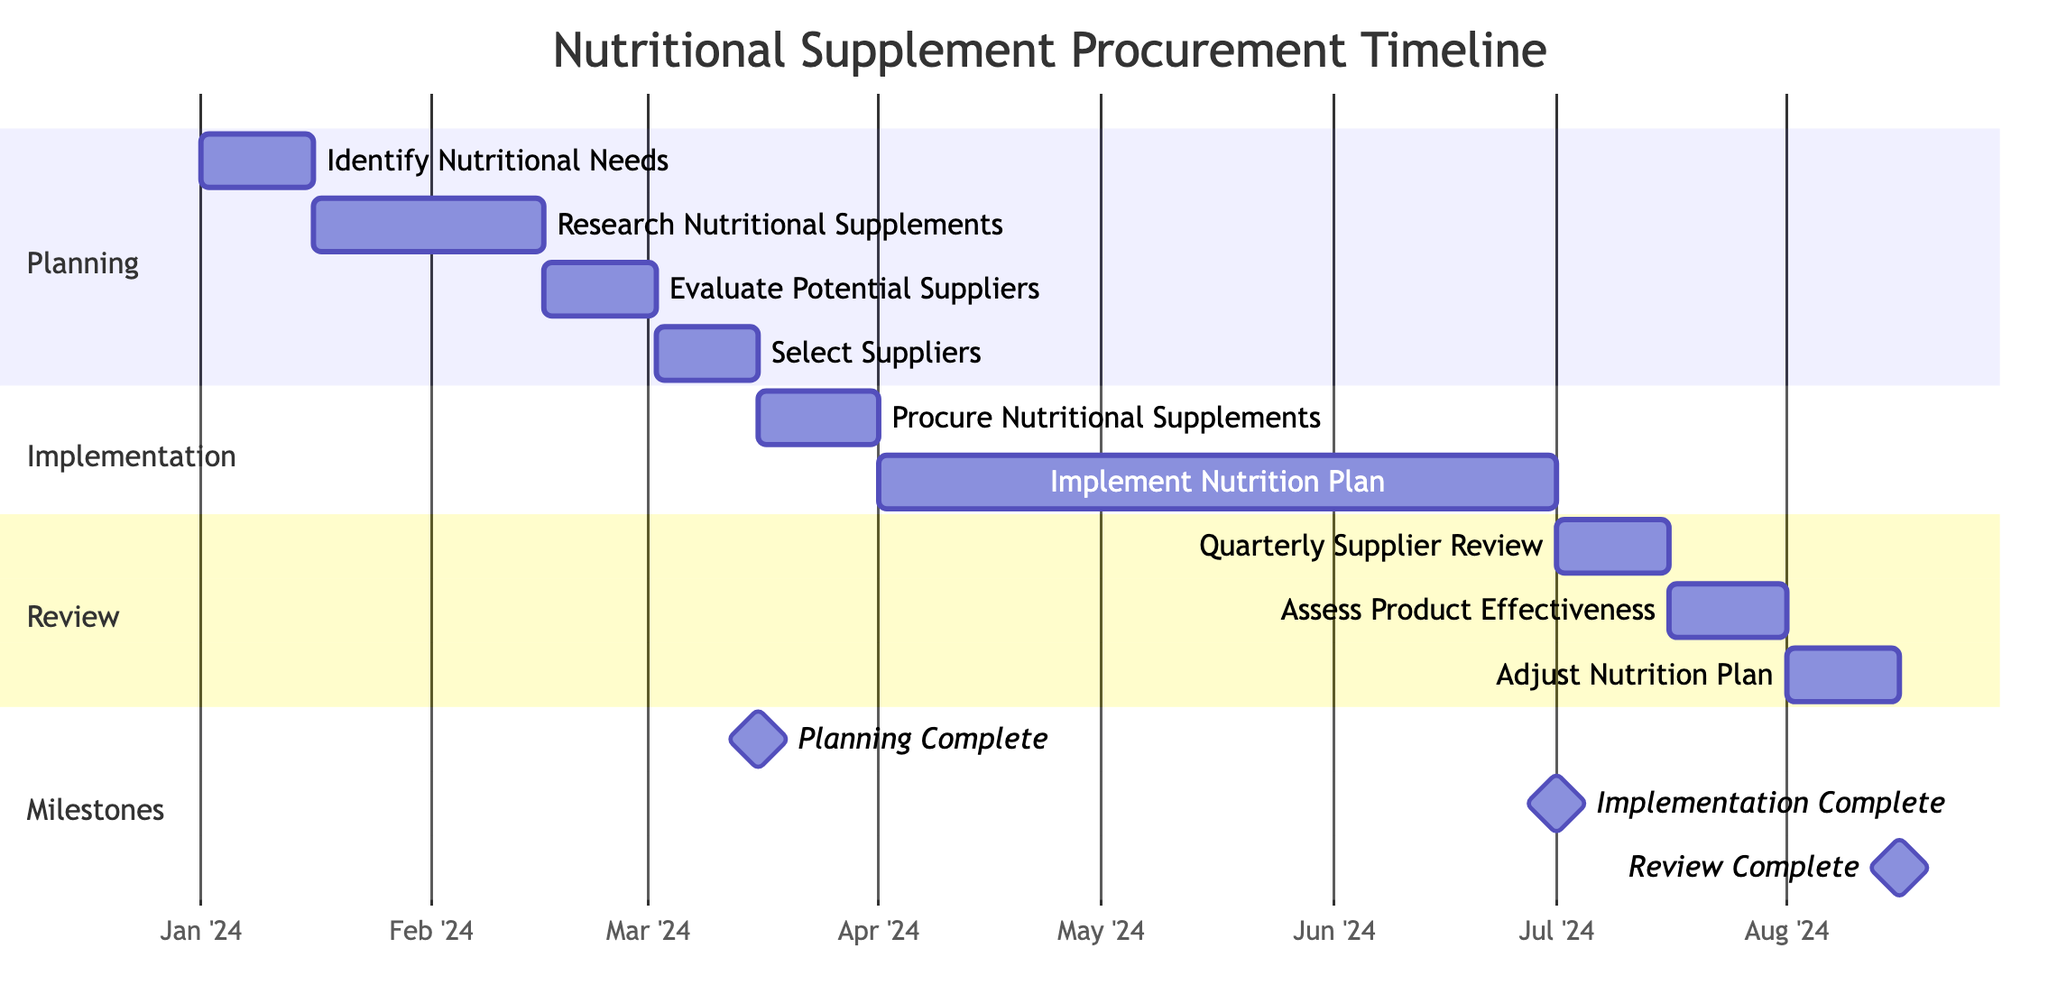What is the duration for the "Identify Nutritional Needs" task? The "Identify Nutritional Needs" task starts on January 1, 2024 and ends on January 15, 2024. The duration is calculated as the difference between the end date and the start date, which is 15 days.
Answer: 15 days How many tasks are included in the "Implementation" section? The "Implementation" section consists of two tasks: "Procure Nutritional Supplements" and "Implement Nutrition Plan". Counting these gives a total of 2 tasks in that section.
Answer: 2 tasks What is the starting date for the "Quarterly Supplier Review"? The "Quarterly Supplier Review" task begins on July 1, 2024, as indicated in the diagram.
Answer: July 1, 2024 Which task follows "Select Suppliers"? The task that follows "Select Suppliers" is "Procure Nutritional Supplements". This is determined by the sequential flow of tasks in the diagram, starting from "Select Suppliers" leading directly into "Procure Nutritional Supplements".
Answer: Procure Nutritional Supplements How long is the "Implement Nutrition Plan" task? "Implement Nutrition Plan" starts on April 1, 2024, and ends on June 30, 2024. The duration is calculated by finding the difference between these two dates, which results in a duration of 91 days.
Answer: 91 days What is the relationship between "Assess Product Effectiveness" and "Quarterly Supplier Review"? "Assess Product Effectiveness" directly follows "Quarterly Supplier Review" in the diagram. This relationship indicates that the assessment occurs after the quarterly review has been completed.
Answer: Sequential relationship When is the next review after the "Assess Product Effectiveness"? The task following "Assess Product Effectiveness" is "Adjust Nutrition Plan". This follows the same sequential structure present in the diagram, directly indicating what comes next after the effectiveness assessment.
Answer: Adjust Nutrition Plan How many milestones are presented in total on the diagram? The diagram shows three milestones: "Planning Complete", "Implementation Complete", and "Review Complete". Counting these gives a total of 3 milestones.
Answer: 3 milestones 